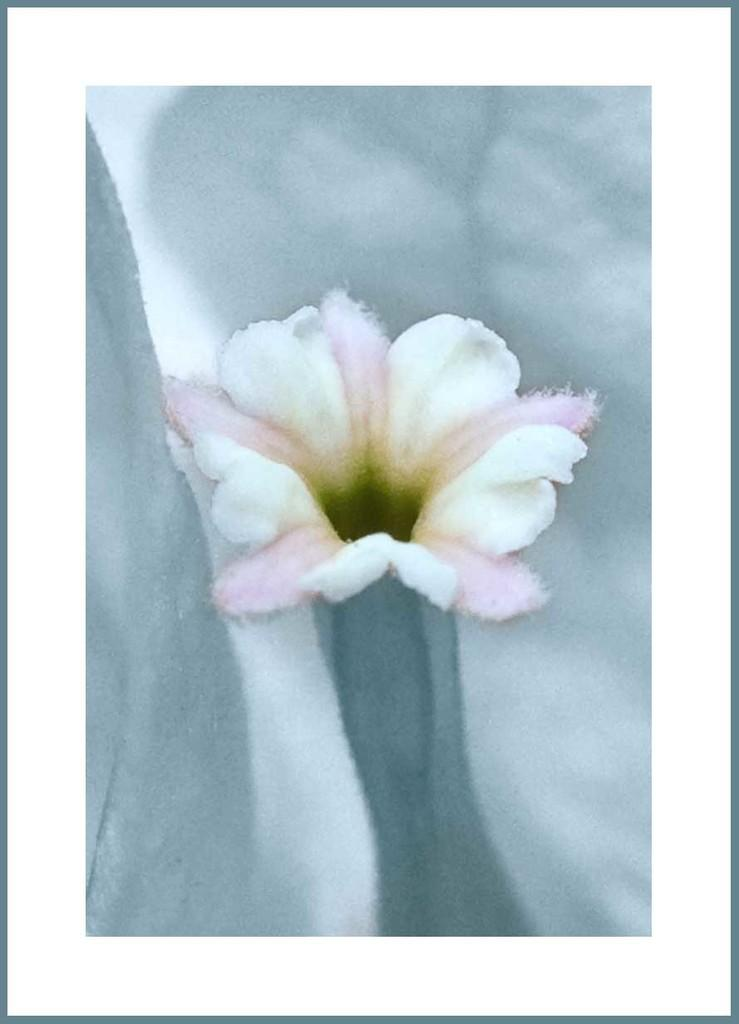What is the main subject of the image? The main subject of the image is a painting of a flower. Can you describe the painting in more detail? Unfortunately, the provided facts do not offer any additional details about the painting. How many cherries are on top of the cake in the image? There is no cake or cherries present in the image; it contains a painting of a flower. 